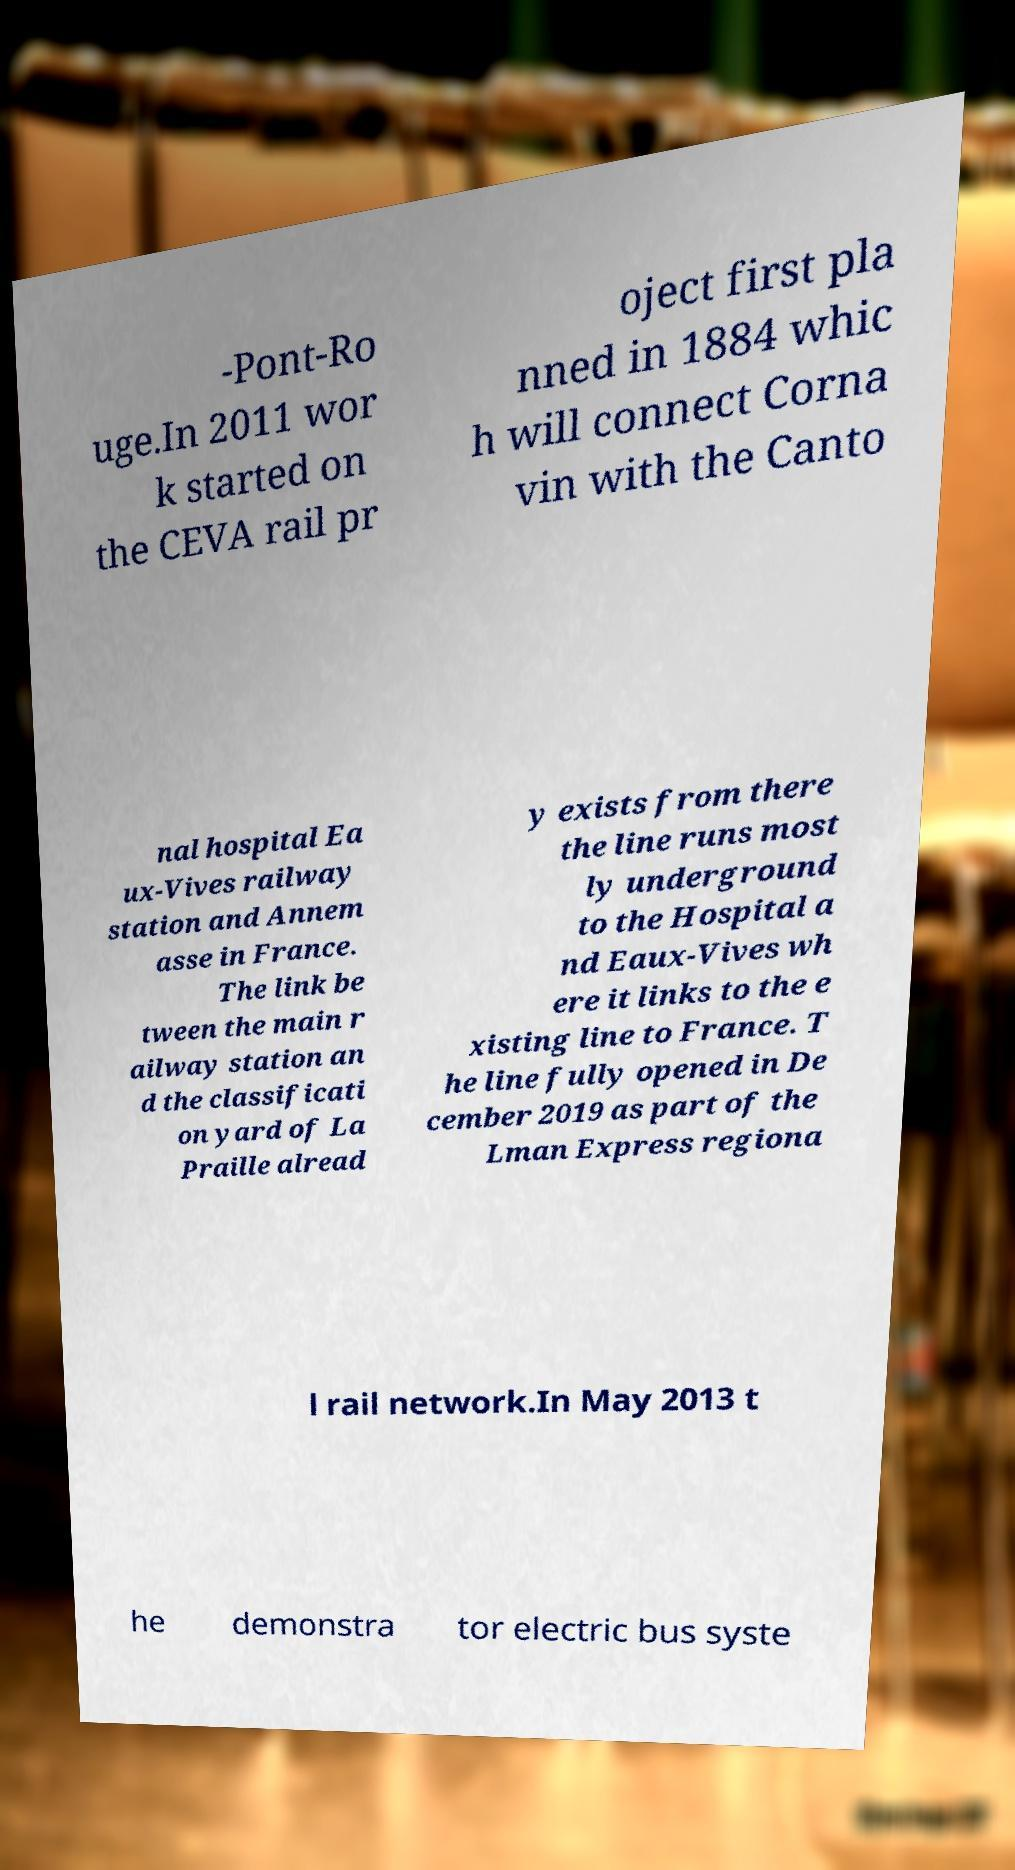What messages or text are displayed in this image? I need them in a readable, typed format. -Pont-Ro uge.In 2011 wor k started on the CEVA rail pr oject first pla nned in 1884 whic h will connect Corna vin with the Canto nal hospital Ea ux-Vives railway station and Annem asse in France. The link be tween the main r ailway station an d the classificati on yard of La Praille alread y exists from there the line runs most ly underground to the Hospital a nd Eaux-Vives wh ere it links to the e xisting line to France. T he line fully opened in De cember 2019 as part of the Lman Express regiona l rail network.In May 2013 t he demonstra tor electric bus syste 